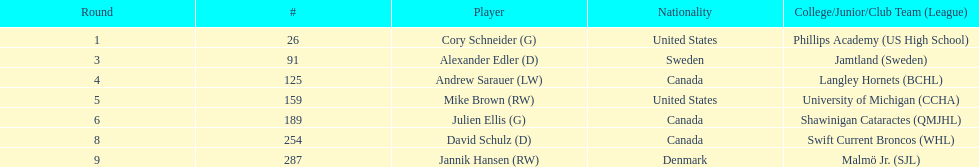Which round did not include a draft pick for the first time? 2. 